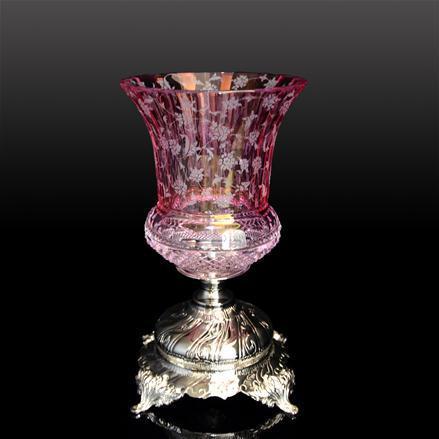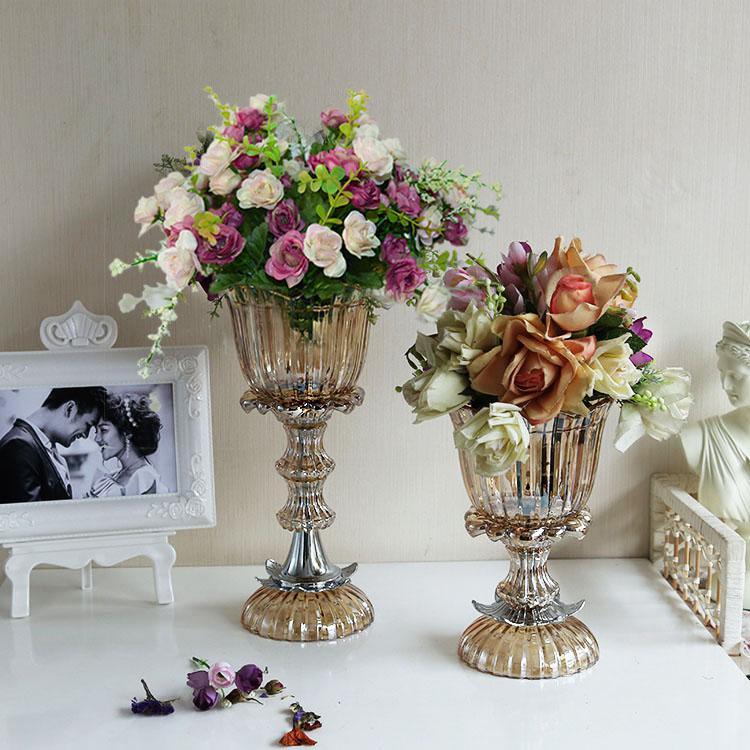The first image is the image on the left, the second image is the image on the right. Given the left and right images, does the statement "There are two clear vases in one of the images." hold true? Answer yes or no. Yes. 